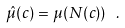<formula> <loc_0><loc_0><loc_500><loc_500>\hat { \mu } ( c ) = \mu ( N ( c ) ) \ .</formula> 